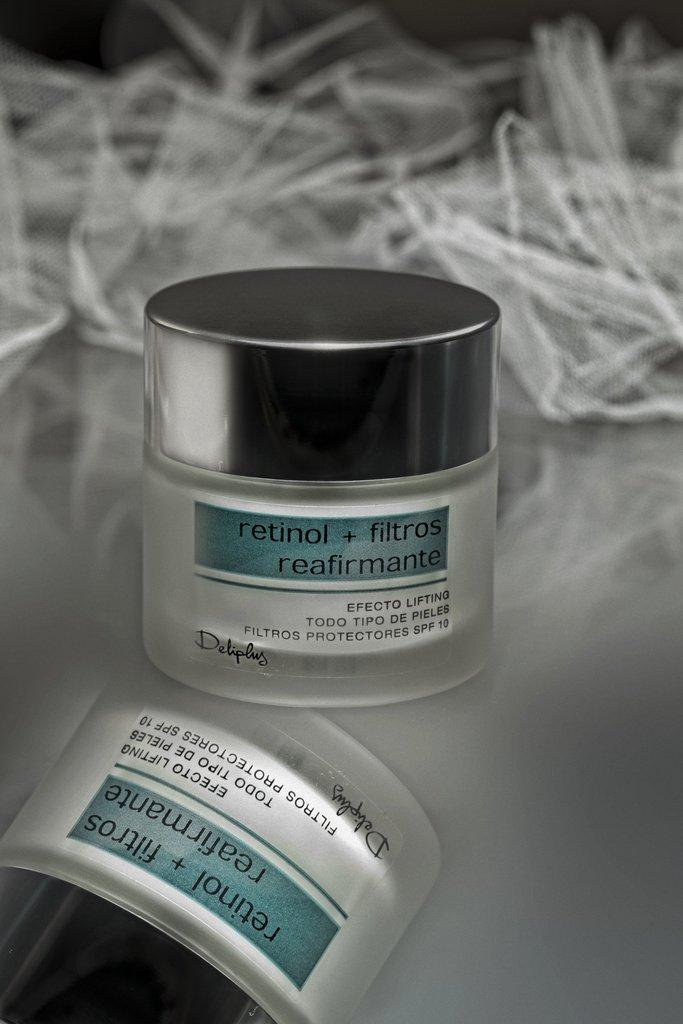What type of surface is visible in the image? There is a mirror surface in the image. What object is placed on the mirror surface? There is a small box on the mirror surface. What is written on the small box? The text "RETINOL+FILTROS" is written on the small box. What type of machine can be seen operating near the seashore in the image? There is no machine or seashore present in the image; it only features a mirror surface with a small box on it. What is the weather like in the image? The image does not provide any information about the weather, as it only shows a mirror surface with a small box on it. 